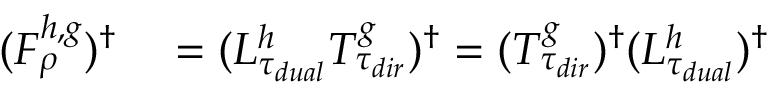Convert formula to latex. <formula><loc_0><loc_0><loc_500><loc_500>\begin{array} { r l } { ( F _ { \rho } ^ { h , g } ) ^ { \dagger } } & = ( L _ { \tau _ { d u a l } } ^ { h } T _ { \tau _ { d i r } } ^ { g } ) ^ { \dagger } = ( T _ { \tau _ { d i r } } ^ { g } ) ^ { \dagger } ( L _ { \tau _ { d u a l } } ^ { h } ) ^ { \dagger } } \end{array}</formula> 